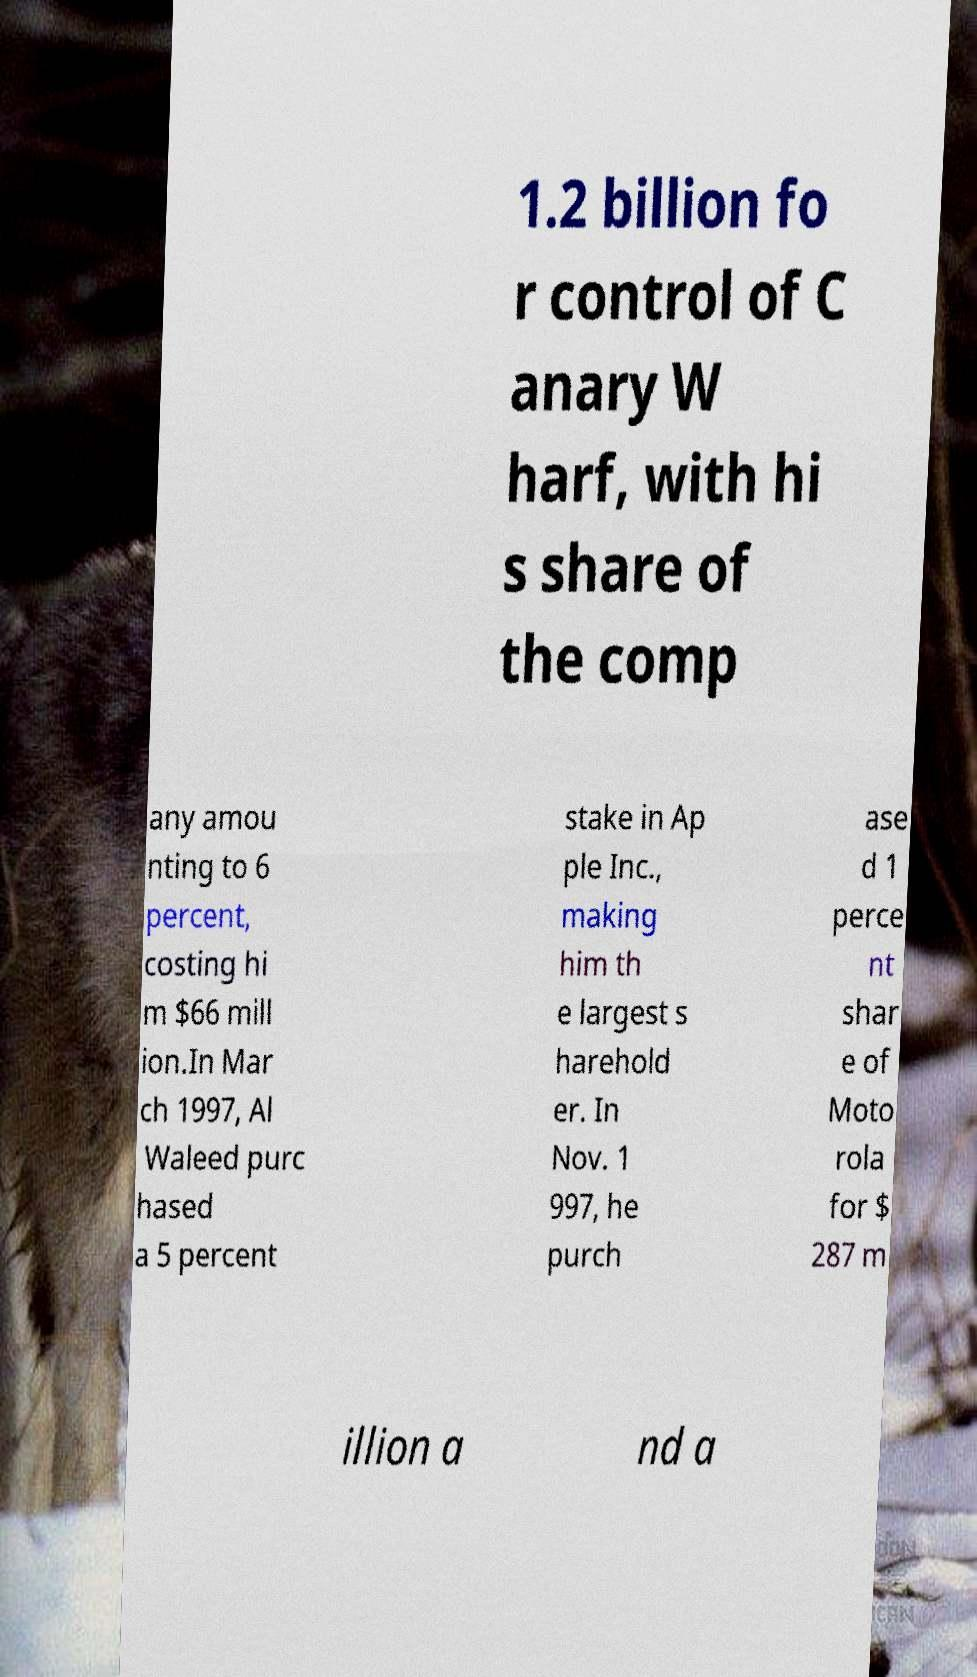Please identify and transcribe the text found in this image. 1.2 billion fo r control of C anary W harf, with hi s share of the comp any amou nting to 6 percent, costing hi m $66 mill ion.In Mar ch 1997, Al Waleed purc hased a 5 percent stake in Ap ple Inc., making him th e largest s harehold er. In Nov. 1 997, he purch ase d 1 perce nt shar e of Moto rola for $ 287 m illion a nd a 